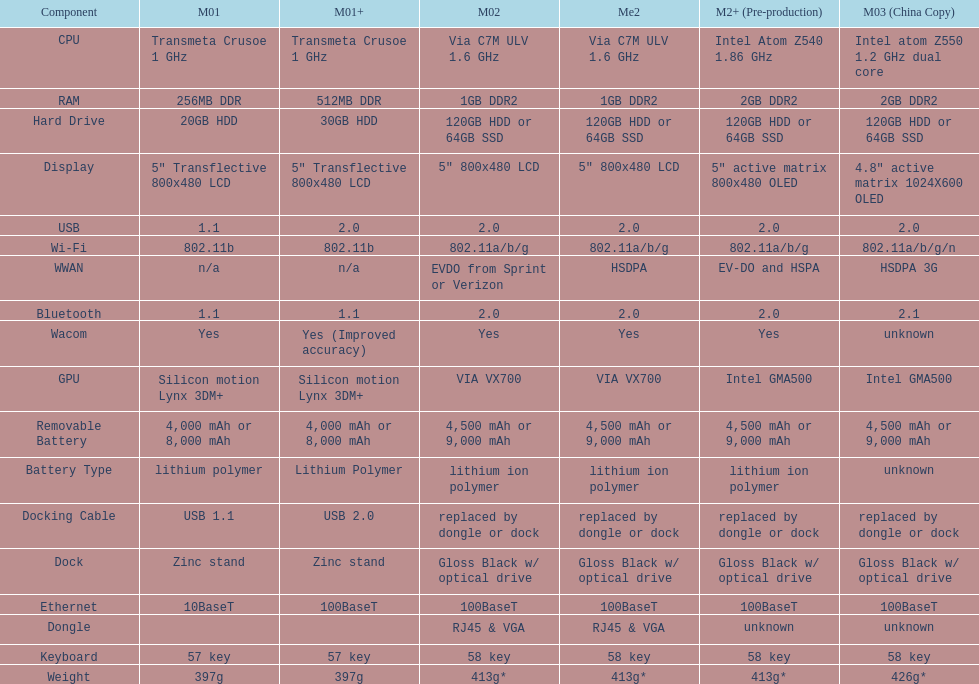Which model weighs the most, according to the table? Model 03 (china copy). 